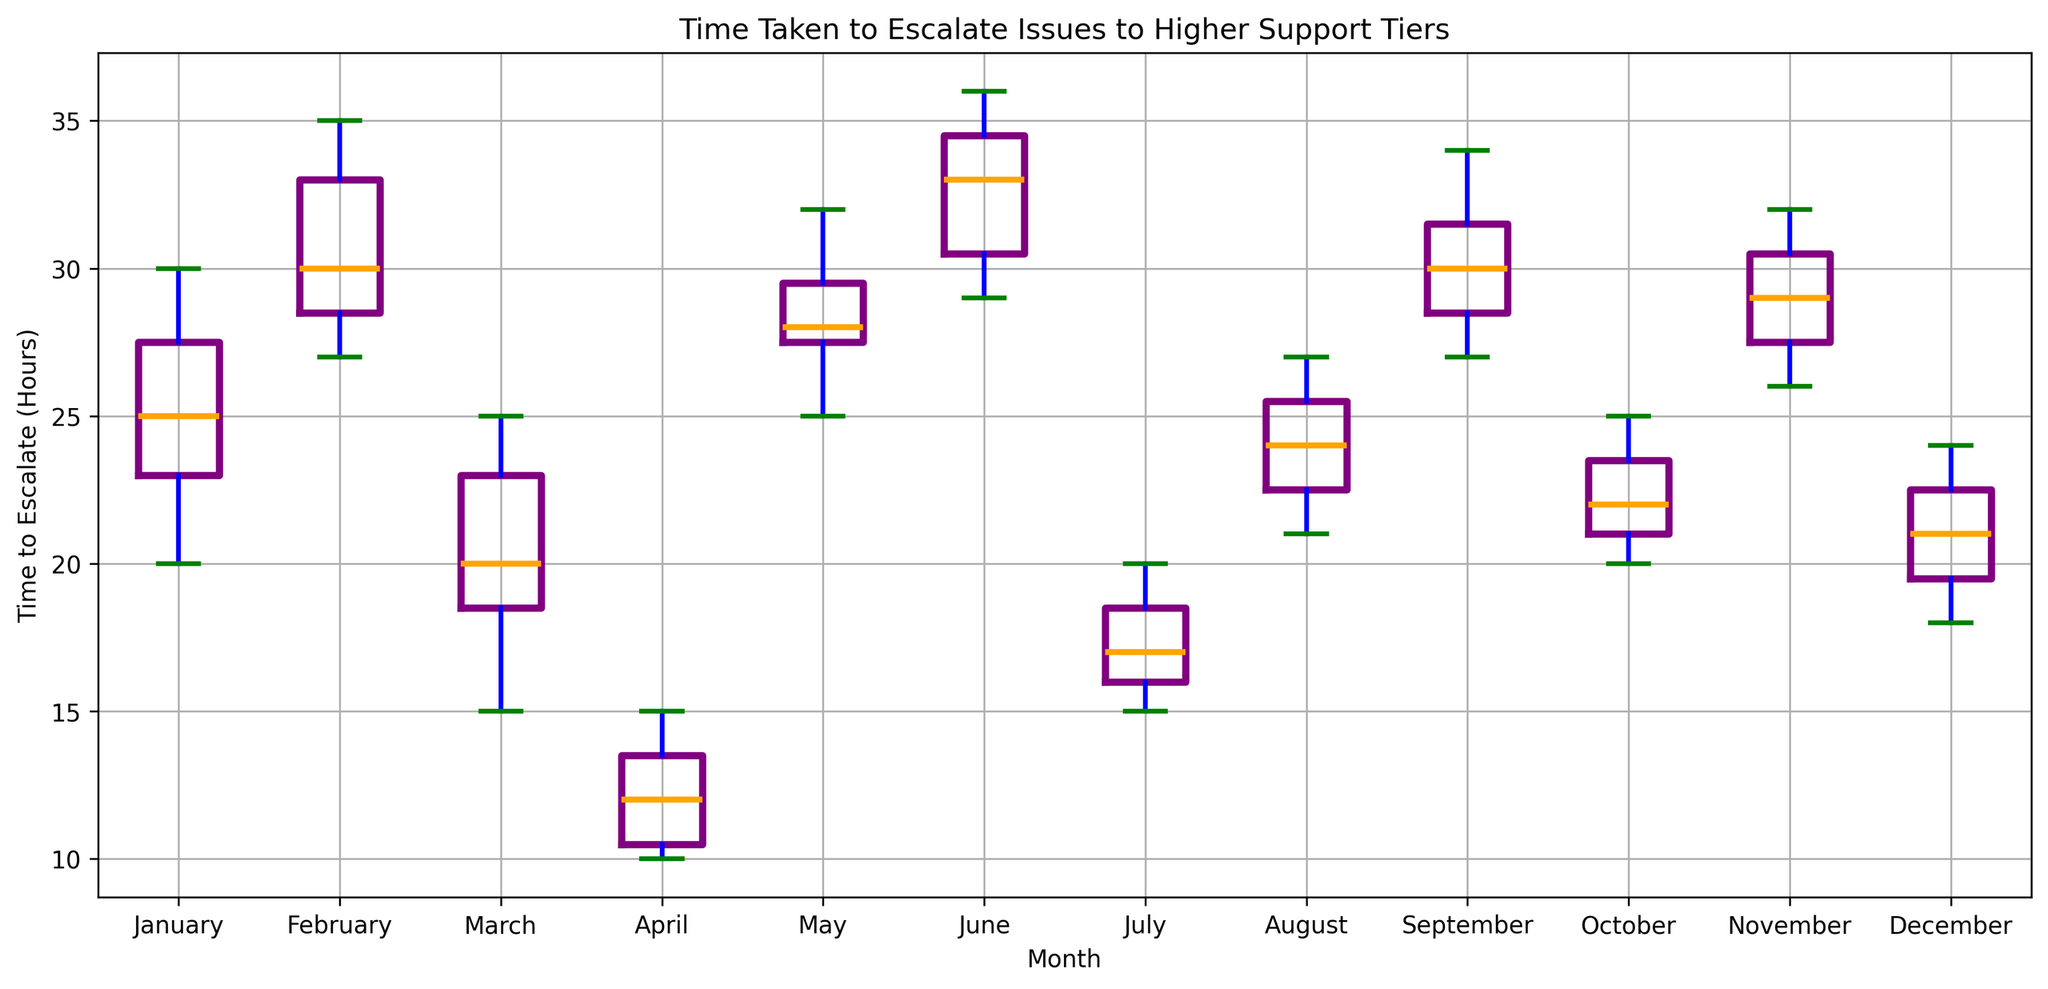What is the median time to escalate issues in March? The middle value of escalation times in March (when arranged in order) is the median. The values are 15, 18, 19, 20, 22, 24, and 25. Therefore, the median is 20.
Answer: 20 Which month has the longest whiskers for time to escalate issues? The whiskers represent the range of the data (excluding outliers). The month with the longest whiskers has the greatest range in escalation time. From the plot, May has a wide range, with whiskers extending from about 25 to 32 hours.
Answer: May How do the median escalation times in January and July compare? The median is represented by the middle line inside the box. In January, it is around 25 hours, and in July, it is about 17 hours. So, the median time in January is longer.
Answer: January's median is longer Which month shows the smallest interquartile range (IQR) for escalation times? IQR is the range between the first quartile (Q1) and the third quartile (Q3). April has a very small box, indicating a small IQR.
Answer: April What is the difference between the maximum escalation time in February and December? The maximum values are represented by the top whisker end or outlier. February's maximum is about 35 hours, while December's maximum is 24 hours. The difference is 35 - 24 = 11 hours.
Answer: 11 hours Which month has the most consistent escalation times? Consistency can be observed by the size of the box (IQR) and the length of whiskers. April has the smallest IQR and shortest whiskers, indicating the most consistent times.
Answer: April What is the median escalation time over the summer months (June, July, August)? Calculate the median for each summer month and then find the median of these values. June: ~33 hours. July: ~17 hours. August: ~24 hours. The median of 33, 17, and 24 is 24.
Answer: 24 hours Are there any months where the escalation times have outliers? If so, which ones? Outliers are shown as red dots outside the whiskers. The months with outliers are May and February.
Answer: May and February How does the range of escalation times in September compare to that in June? Range is determined by the distance between the minimum and maximum values. September's range appears to be from about 27 to 34 hours, while June's range is from 29 to 36 hours. June's range is slightly larger.
Answer: June's range is larger 